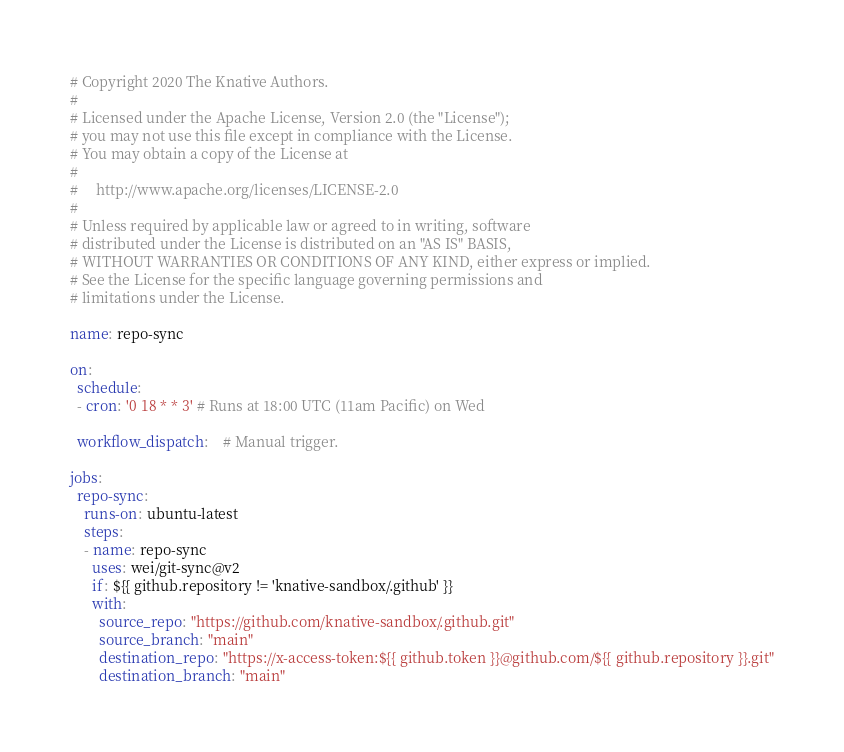<code> <loc_0><loc_0><loc_500><loc_500><_YAML_># Copyright 2020 The Knative Authors.
#
# Licensed under the Apache License, Version 2.0 (the "License");
# you may not use this file except in compliance with the License.
# You may obtain a copy of the License at
#
#     http://www.apache.org/licenses/LICENSE-2.0
#
# Unless required by applicable law or agreed to in writing, software
# distributed under the License is distributed on an "AS IS" BASIS,
# WITHOUT WARRANTIES OR CONDITIONS OF ANY KIND, either express or implied.
# See the License for the specific language governing permissions and
# limitations under the License.

name: repo-sync

on:
  schedule:
  - cron: '0 18 * * 3' # Runs at 18:00 UTC (11am Pacific) on Wed

  workflow_dispatch:    # Manual trigger.

jobs:
  repo-sync:
    runs-on: ubuntu-latest
    steps:
    - name: repo-sync
      uses: wei/git-sync@v2
      if: ${{ github.repository != 'knative-sandbox/.github' }}
      with:
        source_repo: "https://github.com/knative-sandbox/.github.git"
        source_branch: "main"
        destination_repo: "https://x-access-token:${{ github.token }}@github.com/${{ github.repository }}.git"
        destination_branch: "main"
</code> 